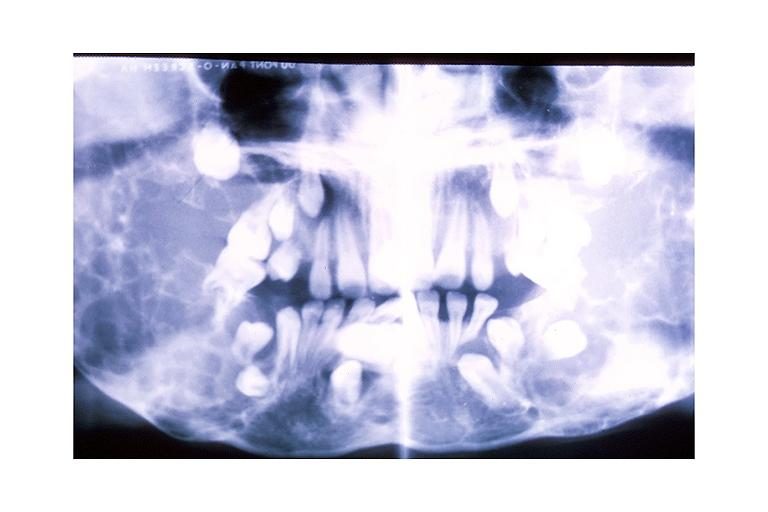what is present?
Answer the question using a single word or phrase. Oral 